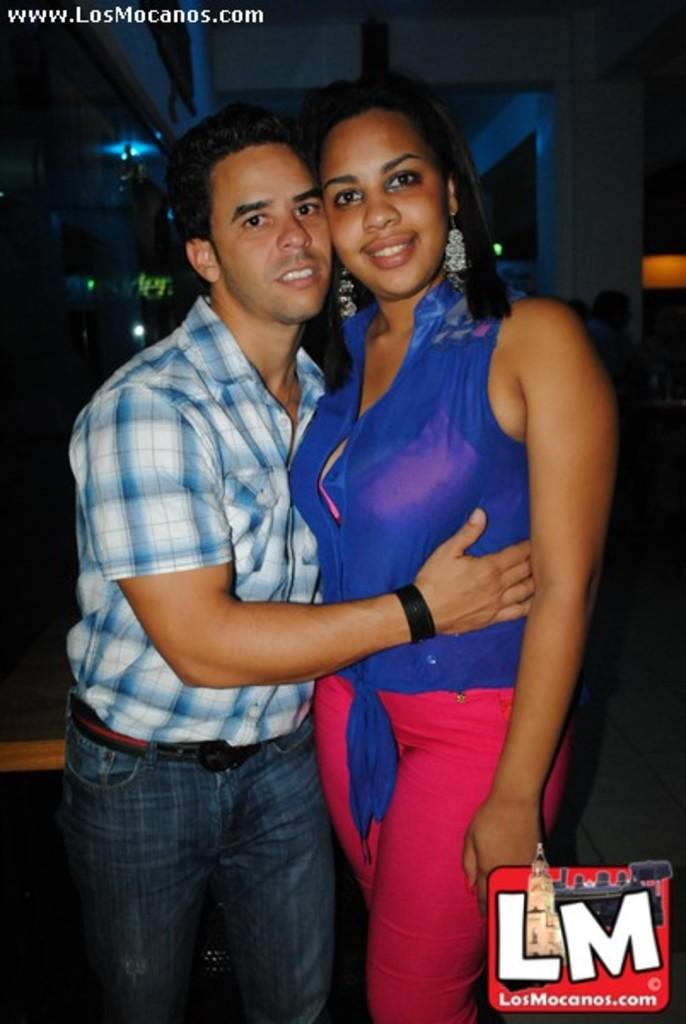Who are the main subjects in the image? There is a couple in the middle of the image. Can you describe the positions of the individuals in the image? There is a woman on the right side of the image and a man on the left side of the image. What are the couple doing in the image? The couple is holding each other. What type of hole can be seen in the image? There is no hole present in the image. Can you describe the ghost in the image? There is no ghost present in the image. 